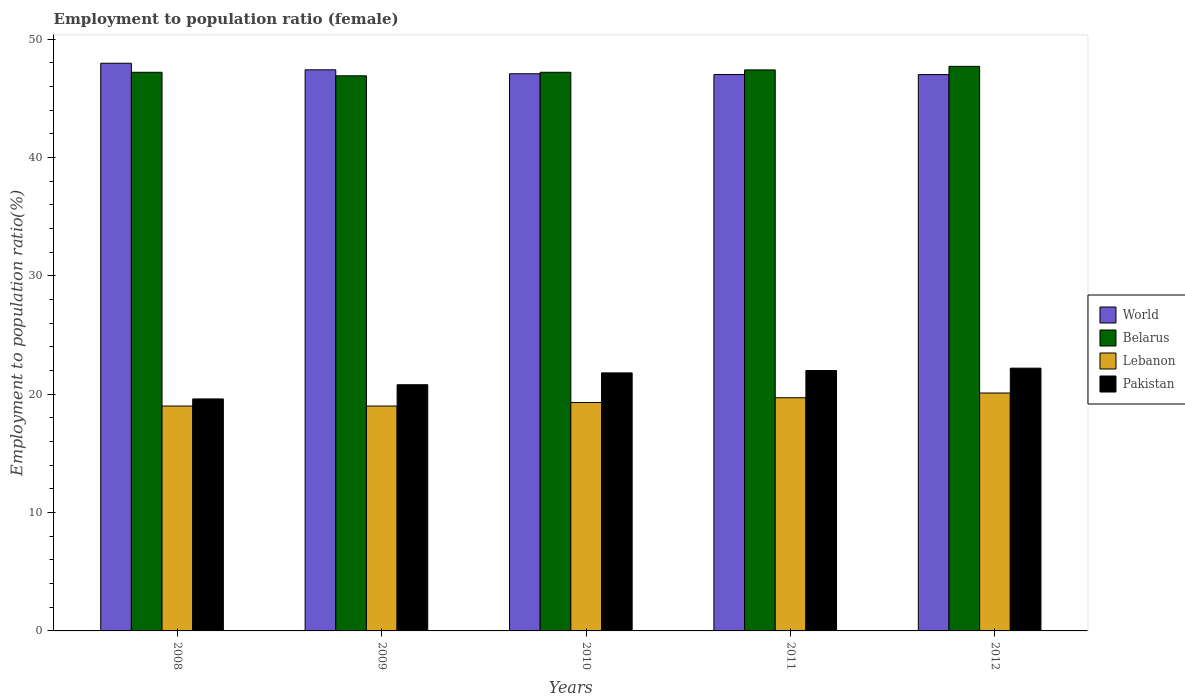How many groups of bars are there?
Your answer should be very brief. 5. How many bars are there on the 5th tick from the left?
Your answer should be very brief. 4. What is the label of the 1st group of bars from the left?
Provide a succinct answer. 2008. What is the employment to population ratio in World in 2008?
Offer a very short reply. 47.96. Across all years, what is the maximum employment to population ratio in World?
Your answer should be compact. 47.96. Across all years, what is the minimum employment to population ratio in Belarus?
Give a very brief answer. 46.9. In which year was the employment to population ratio in Belarus maximum?
Ensure brevity in your answer.  2012. In which year was the employment to population ratio in Belarus minimum?
Your response must be concise. 2009. What is the total employment to population ratio in World in the graph?
Keep it short and to the point. 236.46. What is the difference between the employment to population ratio in Lebanon in 2009 and that in 2012?
Your answer should be very brief. -1.1. What is the difference between the employment to population ratio in Pakistan in 2008 and the employment to population ratio in World in 2009?
Provide a short and direct response. -27.81. What is the average employment to population ratio in World per year?
Ensure brevity in your answer.  47.29. In the year 2011, what is the difference between the employment to population ratio in Lebanon and employment to population ratio in World?
Provide a short and direct response. -27.31. What is the ratio of the employment to population ratio in Belarus in 2008 to that in 2011?
Provide a short and direct response. 1. What is the difference between the highest and the second highest employment to population ratio in World?
Offer a terse response. 0.55. What is the difference between the highest and the lowest employment to population ratio in Lebanon?
Your response must be concise. 1.1. In how many years, is the employment to population ratio in Pakistan greater than the average employment to population ratio in Pakistan taken over all years?
Ensure brevity in your answer.  3. Is the sum of the employment to population ratio in World in 2009 and 2011 greater than the maximum employment to population ratio in Pakistan across all years?
Offer a very short reply. Yes. Is it the case that in every year, the sum of the employment to population ratio in Pakistan and employment to population ratio in World is greater than the sum of employment to population ratio in Lebanon and employment to population ratio in Belarus?
Give a very brief answer. No. What does the 4th bar from the left in 2012 represents?
Ensure brevity in your answer.  Pakistan. How many years are there in the graph?
Ensure brevity in your answer.  5. What is the difference between two consecutive major ticks on the Y-axis?
Offer a very short reply. 10. Are the values on the major ticks of Y-axis written in scientific E-notation?
Give a very brief answer. No. Does the graph contain any zero values?
Keep it short and to the point. No. Does the graph contain grids?
Your answer should be very brief. No. Where does the legend appear in the graph?
Provide a succinct answer. Center right. How many legend labels are there?
Offer a terse response. 4. What is the title of the graph?
Your answer should be compact. Employment to population ratio (female). What is the label or title of the Y-axis?
Ensure brevity in your answer.  Employment to population ratio(%). What is the Employment to population ratio(%) of World in 2008?
Keep it short and to the point. 47.96. What is the Employment to population ratio(%) in Belarus in 2008?
Provide a succinct answer. 47.2. What is the Employment to population ratio(%) in Lebanon in 2008?
Your answer should be very brief. 19. What is the Employment to population ratio(%) in Pakistan in 2008?
Offer a terse response. 19.6. What is the Employment to population ratio(%) of World in 2009?
Provide a succinct answer. 47.41. What is the Employment to population ratio(%) of Belarus in 2009?
Your answer should be compact. 46.9. What is the Employment to population ratio(%) in Lebanon in 2009?
Your answer should be compact. 19. What is the Employment to population ratio(%) in Pakistan in 2009?
Provide a short and direct response. 20.8. What is the Employment to population ratio(%) of World in 2010?
Give a very brief answer. 47.07. What is the Employment to population ratio(%) in Belarus in 2010?
Your answer should be compact. 47.2. What is the Employment to population ratio(%) of Lebanon in 2010?
Your response must be concise. 19.3. What is the Employment to population ratio(%) of Pakistan in 2010?
Make the answer very short. 21.8. What is the Employment to population ratio(%) in World in 2011?
Your answer should be compact. 47.01. What is the Employment to population ratio(%) of Belarus in 2011?
Give a very brief answer. 47.4. What is the Employment to population ratio(%) of Lebanon in 2011?
Offer a terse response. 19.7. What is the Employment to population ratio(%) of World in 2012?
Offer a very short reply. 47.01. What is the Employment to population ratio(%) in Belarus in 2012?
Your answer should be very brief. 47.7. What is the Employment to population ratio(%) of Lebanon in 2012?
Make the answer very short. 20.1. What is the Employment to population ratio(%) of Pakistan in 2012?
Your response must be concise. 22.2. Across all years, what is the maximum Employment to population ratio(%) in World?
Your answer should be very brief. 47.96. Across all years, what is the maximum Employment to population ratio(%) of Belarus?
Keep it short and to the point. 47.7. Across all years, what is the maximum Employment to population ratio(%) of Lebanon?
Your answer should be very brief. 20.1. Across all years, what is the maximum Employment to population ratio(%) in Pakistan?
Give a very brief answer. 22.2. Across all years, what is the minimum Employment to population ratio(%) of World?
Provide a short and direct response. 47.01. Across all years, what is the minimum Employment to population ratio(%) of Belarus?
Give a very brief answer. 46.9. Across all years, what is the minimum Employment to population ratio(%) in Lebanon?
Offer a terse response. 19. Across all years, what is the minimum Employment to population ratio(%) in Pakistan?
Make the answer very short. 19.6. What is the total Employment to population ratio(%) of World in the graph?
Keep it short and to the point. 236.46. What is the total Employment to population ratio(%) of Belarus in the graph?
Your response must be concise. 236.4. What is the total Employment to population ratio(%) in Lebanon in the graph?
Your answer should be compact. 97.1. What is the total Employment to population ratio(%) in Pakistan in the graph?
Provide a short and direct response. 106.4. What is the difference between the Employment to population ratio(%) of World in 2008 and that in 2009?
Make the answer very short. 0.55. What is the difference between the Employment to population ratio(%) of Lebanon in 2008 and that in 2009?
Keep it short and to the point. 0. What is the difference between the Employment to population ratio(%) in World in 2008 and that in 2010?
Keep it short and to the point. 0.89. What is the difference between the Employment to population ratio(%) in World in 2008 and that in 2011?
Your response must be concise. 0.95. What is the difference between the Employment to population ratio(%) in Belarus in 2008 and that in 2011?
Ensure brevity in your answer.  -0.2. What is the difference between the Employment to population ratio(%) of Lebanon in 2008 and that in 2011?
Offer a very short reply. -0.7. What is the difference between the Employment to population ratio(%) in Pakistan in 2008 and that in 2011?
Your answer should be very brief. -2.4. What is the difference between the Employment to population ratio(%) of World in 2008 and that in 2012?
Your answer should be very brief. 0.96. What is the difference between the Employment to population ratio(%) of Pakistan in 2008 and that in 2012?
Offer a terse response. -2.6. What is the difference between the Employment to population ratio(%) of World in 2009 and that in 2010?
Make the answer very short. 0.33. What is the difference between the Employment to population ratio(%) of Pakistan in 2009 and that in 2010?
Provide a succinct answer. -1. What is the difference between the Employment to population ratio(%) of World in 2009 and that in 2011?
Offer a terse response. 0.4. What is the difference between the Employment to population ratio(%) of Belarus in 2009 and that in 2011?
Your answer should be very brief. -0.5. What is the difference between the Employment to population ratio(%) in World in 2009 and that in 2012?
Keep it short and to the point. 0.4. What is the difference between the Employment to population ratio(%) of World in 2010 and that in 2011?
Offer a very short reply. 0.06. What is the difference between the Employment to population ratio(%) of Belarus in 2010 and that in 2011?
Offer a very short reply. -0.2. What is the difference between the Employment to population ratio(%) in Lebanon in 2010 and that in 2011?
Offer a very short reply. -0.4. What is the difference between the Employment to population ratio(%) in World in 2010 and that in 2012?
Give a very brief answer. 0.07. What is the difference between the Employment to population ratio(%) of World in 2011 and that in 2012?
Provide a succinct answer. 0. What is the difference between the Employment to population ratio(%) of Belarus in 2011 and that in 2012?
Offer a very short reply. -0.3. What is the difference between the Employment to population ratio(%) in Lebanon in 2011 and that in 2012?
Your answer should be compact. -0.4. What is the difference between the Employment to population ratio(%) in Pakistan in 2011 and that in 2012?
Make the answer very short. -0.2. What is the difference between the Employment to population ratio(%) in World in 2008 and the Employment to population ratio(%) in Belarus in 2009?
Give a very brief answer. 1.06. What is the difference between the Employment to population ratio(%) of World in 2008 and the Employment to population ratio(%) of Lebanon in 2009?
Make the answer very short. 28.96. What is the difference between the Employment to population ratio(%) in World in 2008 and the Employment to population ratio(%) in Pakistan in 2009?
Offer a terse response. 27.16. What is the difference between the Employment to population ratio(%) of Belarus in 2008 and the Employment to population ratio(%) of Lebanon in 2009?
Make the answer very short. 28.2. What is the difference between the Employment to population ratio(%) in Belarus in 2008 and the Employment to population ratio(%) in Pakistan in 2009?
Provide a succinct answer. 26.4. What is the difference between the Employment to population ratio(%) of World in 2008 and the Employment to population ratio(%) of Belarus in 2010?
Your answer should be very brief. 0.76. What is the difference between the Employment to population ratio(%) in World in 2008 and the Employment to population ratio(%) in Lebanon in 2010?
Make the answer very short. 28.66. What is the difference between the Employment to population ratio(%) in World in 2008 and the Employment to population ratio(%) in Pakistan in 2010?
Give a very brief answer. 26.16. What is the difference between the Employment to population ratio(%) in Belarus in 2008 and the Employment to population ratio(%) in Lebanon in 2010?
Give a very brief answer. 27.9. What is the difference between the Employment to population ratio(%) in Belarus in 2008 and the Employment to population ratio(%) in Pakistan in 2010?
Provide a short and direct response. 25.4. What is the difference between the Employment to population ratio(%) of World in 2008 and the Employment to population ratio(%) of Belarus in 2011?
Your answer should be very brief. 0.56. What is the difference between the Employment to population ratio(%) of World in 2008 and the Employment to population ratio(%) of Lebanon in 2011?
Your answer should be compact. 28.26. What is the difference between the Employment to population ratio(%) in World in 2008 and the Employment to population ratio(%) in Pakistan in 2011?
Keep it short and to the point. 25.96. What is the difference between the Employment to population ratio(%) in Belarus in 2008 and the Employment to population ratio(%) in Lebanon in 2011?
Keep it short and to the point. 27.5. What is the difference between the Employment to population ratio(%) in Belarus in 2008 and the Employment to population ratio(%) in Pakistan in 2011?
Your response must be concise. 25.2. What is the difference between the Employment to population ratio(%) in World in 2008 and the Employment to population ratio(%) in Belarus in 2012?
Offer a very short reply. 0.26. What is the difference between the Employment to population ratio(%) in World in 2008 and the Employment to population ratio(%) in Lebanon in 2012?
Ensure brevity in your answer.  27.86. What is the difference between the Employment to population ratio(%) of World in 2008 and the Employment to population ratio(%) of Pakistan in 2012?
Your answer should be very brief. 25.76. What is the difference between the Employment to population ratio(%) of Belarus in 2008 and the Employment to population ratio(%) of Lebanon in 2012?
Provide a succinct answer. 27.1. What is the difference between the Employment to population ratio(%) in World in 2009 and the Employment to population ratio(%) in Belarus in 2010?
Provide a short and direct response. 0.21. What is the difference between the Employment to population ratio(%) of World in 2009 and the Employment to population ratio(%) of Lebanon in 2010?
Provide a succinct answer. 28.11. What is the difference between the Employment to population ratio(%) in World in 2009 and the Employment to population ratio(%) in Pakistan in 2010?
Your response must be concise. 25.61. What is the difference between the Employment to population ratio(%) in Belarus in 2009 and the Employment to population ratio(%) in Lebanon in 2010?
Provide a short and direct response. 27.6. What is the difference between the Employment to population ratio(%) of Belarus in 2009 and the Employment to population ratio(%) of Pakistan in 2010?
Keep it short and to the point. 25.1. What is the difference between the Employment to population ratio(%) in Lebanon in 2009 and the Employment to population ratio(%) in Pakistan in 2010?
Give a very brief answer. -2.8. What is the difference between the Employment to population ratio(%) of World in 2009 and the Employment to population ratio(%) of Belarus in 2011?
Keep it short and to the point. 0.01. What is the difference between the Employment to population ratio(%) in World in 2009 and the Employment to population ratio(%) in Lebanon in 2011?
Ensure brevity in your answer.  27.71. What is the difference between the Employment to population ratio(%) of World in 2009 and the Employment to population ratio(%) of Pakistan in 2011?
Your answer should be compact. 25.41. What is the difference between the Employment to population ratio(%) in Belarus in 2009 and the Employment to population ratio(%) in Lebanon in 2011?
Your answer should be compact. 27.2. What is the difference between the Employment to population ratio(%) of Belarus in 2009 and the Employment to population ratio(%) of Pakistan in 2011?
Offer a very short reply. 24.9. What is the difference between the Employment to population ratio(%) in Lebanon in 2009 and the Employment to population ratio(%) in Pakistan in 2011?
Make the answer very short. -3. What is the difference between the Employment to population ratio(%) of World in 2009 and the Employment to population ratio(%) of Belarus in 2012?
Offer a terse response. -0.29. What is the difference between the Employment to population ratio(%) of World in 2009 and the Employment to population ratio(%) of Lebanon in 2012?
Your response must be concise. 27.31. What is the difference between the Employment to population ratio(%) of World in 2009 and the Employment to population ratio(%) of Pakistan in 2012?
Provide a succinct answer. 25.21. What is the difference between the Employment to population ratio(%) of Belarus in 2009 and the Employment to population ratio(%) of Lebanon in 2012?
Make the answer very short. 26.8. What is the difference between the Employment to population ratio(%) of Belarus in 2009 and the Employment to population ratio(%) of Pakistan in 2012?
Provide a short and direct response. 24.7. What is the difference between the Employment to population ratio(%) in World in 2010 and the Employment to population ratio(%) in Belarus in 2011?
Make the answer very short. -0.33. What is the difference between the Employment to population ratio(%) in World in 2010 and the Employment to population ratio(%) in Lebanon in 2011?
Provide a succinct answer. 27.37. What is the difference between the Employment to population ratio(%) in World in 2010 and the Employment to population ratio(%) in Pakistan in 2011?
Make the answer very short. 25.07. What is the difference between the Employment to population ratio(%) of Belarus in 2010 and the Employment to population ratio(%) of Pakistan in 2011?
Give a very brief answer. 25.2. What is the difference between the Employment to population ratio(%) of World in 2010 and the Employment to population ratio(%) of Belarus in 2012?
Offer a terse response. -0.63. What is the difference between the Employment to population ratio(%) in World in 2010 and the Employment to population ratio(%) in Lebanon in 2012?
Give a very brief answer. 26.97. What is the difference between the Employment to population ratio(%) of World in 2010 and the Employment to population ratio(%) of Pakistan in 2012?
Your answer should be very brief. 24.87. What is the difference between the Employment to population ratio(%) of Belarus in 2010 and the Employment to population ratio(%) of Lebanon in 2012?
Your answer should be compact. 27.1. What is the difference between the Employment to population ratio(%) of World in 2011 and the Employment to population ratio(%) of Belarus in 2012?
Give a very brief answer. -0.69. What is the difference between the Employment to population ratio(%) in World in 2011 and the Employment to population ratio(%) in Lebanon in 2012?
Your answer should be compact. 26.91. What is the difference between the Employment to population ratio(%) of World in 2011 and the Employment to population ratio(%) of Pakistan in 2012?
Ensure brevity in your answer.  24.81. What is the difference between the Employment to population ratio(%) in Belarus in 2011 and the Employment to population ratio(%) in Lebanon in 2012?
Your response must be concise. 27.3. What is the difference between the Employment to population ratio(%) of Belarus in 2011 and the Employment to population ratio(%) of Pakistan in 2012?
Offer a terse response. 25.2. What is the average Employment to population ratio(%) of World per year?
Provide a short and direct response. 47.29. What is the average Employment to population ratio(%) in Belarus per year?
Your answer should be compact. 47.28. What is the average Employment to population ratio(%) of Lebanon per year?
Provide a short and direct response. 19.42. What is the average Employment to population ratio(%) of Pakistan per year?
Provide a short and direct response. 21.28. In the year 2008, what is the difference between the Employment to population ratio(%) of World and Employment to population ratio(%) of Belarus?
Give a very brief answer. 0.76. In the year 2008, what is the difference between the Employment to population ratio(%) in World and Employment to population ratio(%) in Lebanon?
Your response must be concise. 28.96. In the year 2008, what is the difference between the Employment to population ratio(%) in World and Employment to population ratio(%) in Pakistan?
Provide a succinct answer. 28.36. In the year 2008, what is the difference between the Employment to population ratio(%) in Belarus and Employment to population ratio(%) in Lebanon?
Your response must be concise. 28.2. In the year 2008, what is the difference between the Employment to population ratio(%) of Belarus and Employment to population ratio(%) of Pakistan?
Provide a succinct answer. 27.6. In the year 2008, what is the difference between the Employment to population ratio(%) in Lebanon and Employment to population ratio(%) in Pakistan?
Offer a terse response. -0.6. In the year 2009, what is the difference between the Employment to population ratio(%) of World and Employment to population ratio(%) of Belarus?
Provide a short and direct response. 0.51. In the year 2009, what is the difference between the Employment to population ratio(%) of World and Employment to population ratio(%) of Lebanon?
Give a very brief answer. 28.41. In the year 2009, what is the difference between the Employment to population ratio(%) of World and Employment to population ratio(%) of Pakistan?
Provide a succinct answer. 26.61. In the year 2009, what is the difference between the Employment to population ratio(%) of Belarus and Employment to population ratio(%) of Lebanon?
Ensure brevity in your answer.  27.9. In the year 2009, what is the difference between the Employment to population ratio(%) of Belarus and Employment to population ratio(%) of Pakistan?
Your answer should be very brief. 26.1. In the year 2009, what is the difference between the Employment to population ratio(%) in Lebanon and Employment to population ratio(%) in Pakistan?
Your response must be concise. -1.8. In the year 2010, what is the difference between the Employment to population ratio(%) of World and Employment to population ratio(%) of Belarus?
Keep it short and to the point. -0.13. In the year 2010, what is the difference between the Employment to population ratio(%) in World and Employment to population ratio(%) in Lebanon?
Give a very brief answer. 27.77. In the year 2010, what is the difference between the Employment to population ratio(%) in World and Employment to population ratio(%) in Pakistan?
Provide a succinct answer. 25.27. In the year 2010, what is the difference between the Employment to population ratio(%) of Belarus and Employment to population ratio(%) of Lebanon?
Offer a terse response. 27.9. In the year 2010, what is the difference between the Employment to population ratio(%) of Belarus and Employment to population ratio(%) of Pakistan?
Give a very brief answer. 25.4. In the year 2011, what is the difference between the Employment to population ratio(%) of World and Employment to population ratio(%) of Belarus?
Your answer should be compact. -0.39. In the year 2011, what is the difference between the Employment to population ratio(%) in World and Employment to population ratio(%) in Lebanon?
Ensure brevity in your answer.  27.31. In the year 2011, what is the difference between the Employment to population ratio(%) in World and Employment to population ratio(%) in Pakistan?
Give a very brief answer. 25.01. In the year 2011, what is the difference between the Employment to population ratio(%) in Belarus and Employment to population ratio(%) in Lebanon?
Your answer should be compact. 27.7. In the year 2011, what is the difference between the Employment to population ratio(%) of Belarus and Employment to population ratio(%) of Pakistan?
Keep it short and to the point. 25.4. In the year 2011, what is the difference between the Employment to population ratio(%) in Lebanon and Employment to population ratio(%) in Pakistan?
Keep it short and to the point. -2.3. In the year 2012, what is the difference between the Employment to population ratio(%) of World and Employment to population ratio(%) of Belarus?
Keep it short and to the point. -0.69. In the year 2012, what is the difference between the Employment to population ratio(%) in World and Employment to population ratio(%) in Lebanon?
Offer a very short reply. 26.91. In the year 2012, what is the difference between the Employment to population ratio(%) of World and Employment to population ratio(%) of Pakistan?
Your response must be concise. 24.81. In the year 2012, what is the difference between the Employment to population ratio(%) of Belarus and Employment to population ratio(%) of Lebanon?
Offer a very short reply. 27.6. In the year 2012, what is the difference between the Employment to population ratio(%) in Belarus and Employment to population ratio(%) in Pakistan?
Offer a terse response. 25.5. In the year 2012, what is the difference between the Employment to population ratio(%) in Lebanon and Employment to population ratio(%) in Pakistan?
Provide a short and direct response. -2.1. What is the ratio of the Employment to population ratio(%) in World in 2008 to that in 2009?
Your answer should be very brief. 1.01. What is the ratio of the Employment to population ratio(%) of Belarus in 2008 to that in 2009?
Make the answer very short. 1.01. What is the ratio of the Employment to population ratio(%) of Lebanon in 2008 to that in 2009?
Provide a succinct answer. 1. What is the ratio of the Employment to population ratio(%) of Pakistan in 2008 to that in 2009?
Make the answer very short. 0.94. What is the ratio of the Employment to population ratio(%) of World in 2008 to that in 2010?
Give a very brief answer. 1.02. What is the ratio of the Employment to population ratio(%) in Belarus in 2008 to that in 2010?
Your answer should be compact. 1. What is the ratio of the Employment to population ratio(%) in Lebanon in 2008 to that in 2010?
Provide a short and direct response. 0.98. What is the ratio of the Employment to population ratio(%) in Pakistan in 2008 to that in 2010?
Provide a succinct answer. 0.9. What is the ratio of the Employment to population ratio(%) of World in 2008 to that in 2011?
Provide a succinct answer. 1.02. What is the ratio of the Employment to population ratio(%) in Lebanon in 2008 to that in 2011?
Keep it short and to the point. 0.96. What is the ratio of the Employment to population ratio(%) in Pakistan in 2008 to that in 2011?
Offer a terse response. 0.89. What is the ratio of the Employment to population ratio(%) in World in 2008 to that in 2012?
Your answer should be compact. 1.02. What is the ratio of the Employment to population ratio(%) of Lebanon in 2008 to that in 2012?
Your response must be concise. 0.95. What is the ratio of the Employment to population ratio(%) of Pakistan in 2008 to that in 2012?
Offer a terse response. 0.88. What is the ratio of the Employment to population ratio(%) of World in 2009 to that in 2010?
Ensure brevity in your answer.  1.01. What is the ratio of the Employment to population ratio(%) in Belarus in 2009 to that in 2010?
Offer a terse response. 0.99. What is the ratio of the Employment to population ratio(%) of Lebanon in 2009 to that in 2010?
Offer a terse response. 0.98. What is the ratio of the Employment to population ratio(%) of Pakistan in 2009 to that in 2010?
Your answer should be compact. 0.95. What is the ratio of the Employment to population ratio(%) in World in 2009 to that in 2011?
Give a very brief answer. 1.01. What is the ratio of the Employment to population ratio(%) of Lebanon in 2009 to that in 2011?
Your answer should be compact. 0.96. What is the ratio of the Employment to population ratio(%) in Pakistan in 2009 to that in 2011?
Ensure brevity in your answer.  0.95. What is the ratio of the Employment to population ratio(%) of World in 2009 to that in 2012?
Provide a short and direct response. 1.01. What is the ratio of the Employment to population ratio(%) of Belarus in 2009 to that in 2012?
Offer a terse response. 0.98. What is the ratio of the Employment to population ratio(%) of Lebanon in 2009 to that in 2012?
Offer a very short reply. 0.95. What is the ratio of the Employment to population ratio(%) in Pakistan in 2009 to that in 2012?
Provide a succinct answer. 0.94. What is the ratio of the Employment to population ratio(%) of World in 2010 to that in 2011?
Your answer should be very brief. 1. What is the ratio of the Employment to population ratio(%) of Belarus in 2010 to that in 2011?
Provide a short and direct response. 1. What is the ratio of the Employment to population ratio(%) in Lebanon in 2010 to that in 2011?
Your answer should be very brief. 0.98. What is the ratio of the Employment to population ratio(%) in Pakistan in 2010 to that in 2011?
Ensure brevity in your answer.  0.99. What is the ratio of the Employment to population ratio(%) in Lebanon in 2010 to that in 2012?
Give a very brief answer. 0.96. What is the ratio of the Employment to population ratio(%) in Pakistan in 2010 to that in 2012?
Your answer should be very brief. 0.98. What is the ratio of the Employment to population ratio(%) of Belarus in 2011 to that in 2012?
Provide a succinct answer. 0.99. What is the ratio of the Employment to population ratio(%) in Lebanon in 2011 to that in 2012?
Provide a short and direct response. 0.98. What is the ratio of the Employment to population ratio(%) of Pakistan in 2011 to that in 2012?
Provide a succinct answer. 0.99. What is the difference between the highest and the second highest Employment to population ratio(%) in World?
Provide a short and direct response. 0.55. What is the difference between the highest and the second highest Employment to population ratio(%) of Pakistan?
Your answer should be very brief. 0.2. What is the difference between the highest and the lowest Employment to population ratio(%) of World?
Provide a short and direct response. 0.96. What is the difference between the highest and the lowest Employment to population ratio(%) of Lebanon?
Your response must be concise. 1.1. 